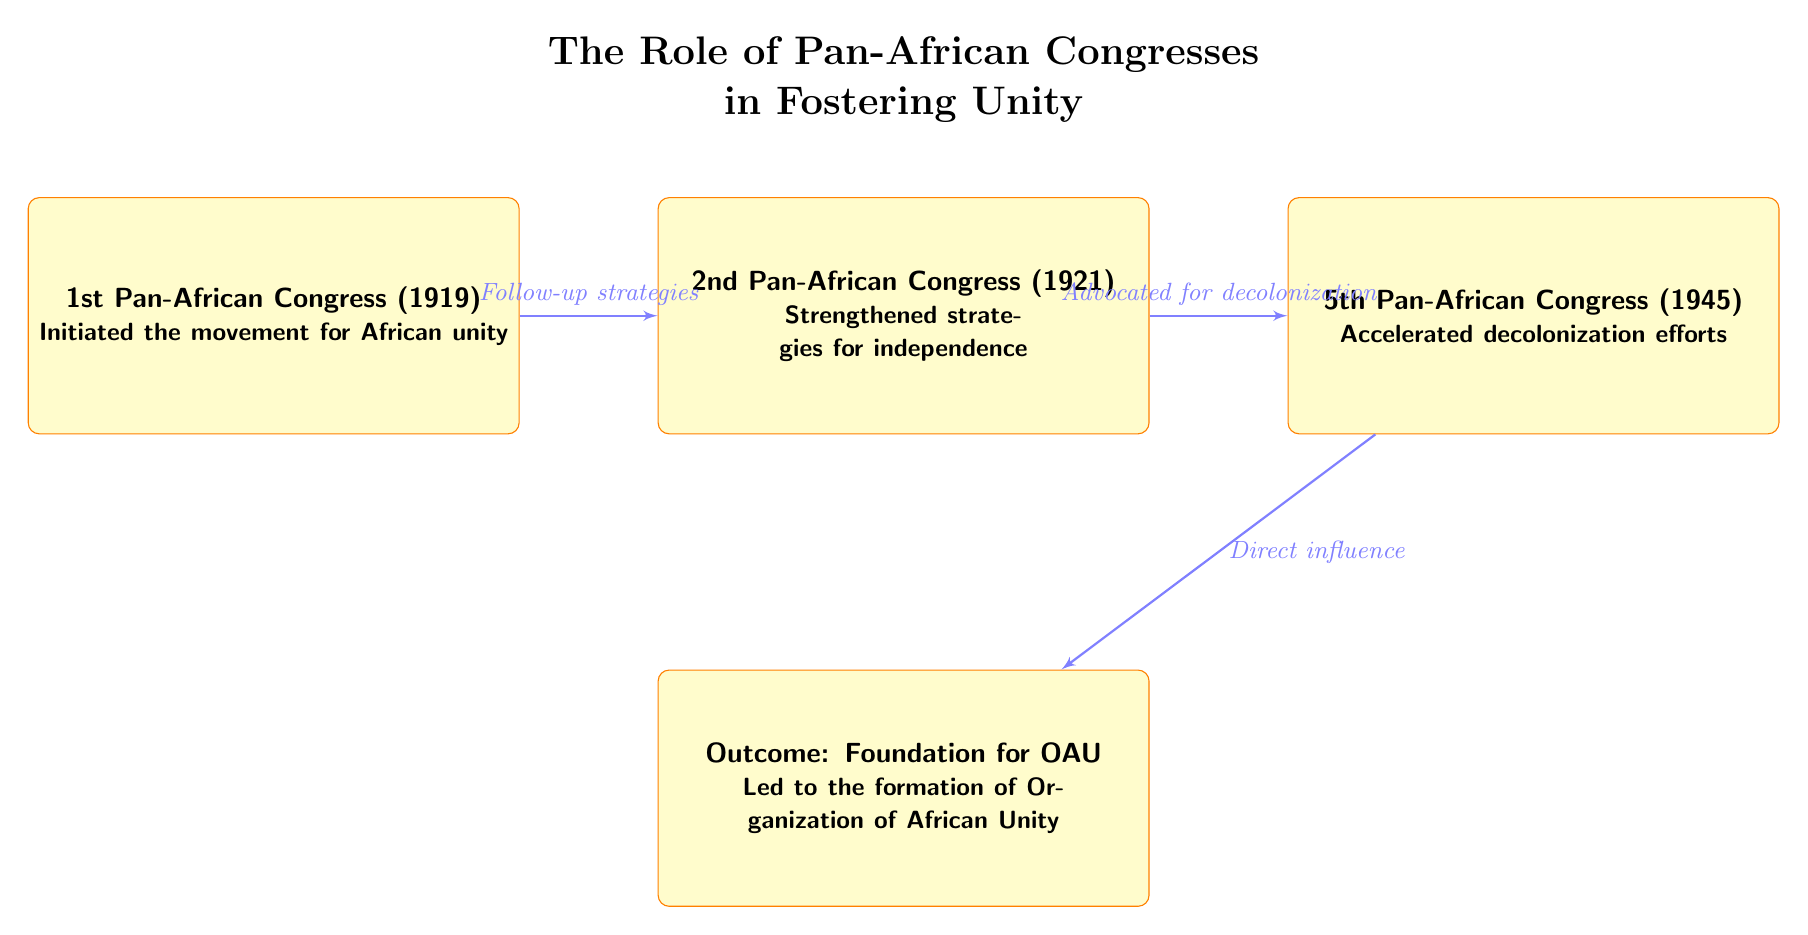What is the first event listed in the diagram? The diagram lists the 1st Pan-African Congress (1919) as the first event. This information is found in the first box at the top left of the flowchart.
Answer: 1st Pan-African Congress (1919) How many major congresses are depicted in the diagram? The diagram includes four major events: the 1st, 2nd, and 5th Pan-African Congresses, as well as the outcome that led to the foundation of the OAU. Counting these boxes shows there are four events in total.
Answer: 4 What was a key outcome of the 5th Pan-African Congress? The 5th Pan-African Congress (1945) resulted in the acceleration of decolonization efforts, as noted in the corresponding box. This outcome leads to the foundation of the OAU.
Answer: Accelerated decolonization efforts What connects the 2nd and 5th Pan-African Congresses? The connection is established through an arrow labeled "Advocated for decolonization," illustrating the flow of influence or strategies between these two congresses.
Answer: Advocated for decolonization What significant foundation resulted from the congresses outlined in the diagram? The diagram mentions that the outcome of the congresses led to the "Foundation for OAU," indicating a significant organizational result stemming from their discussions and strategies.
Answer: Foundation for OAU What year did the 2nd Pan-African Congress take place? The 2nd Pan-African Congress is identified as occurring in 1921 within the flowchart's information in the second box.
Answer: 1921 What do the arrows in the diagram represent? The arrows in the diagram represent the relationships and influences between the congress events, indicating sequential follow-ups and advocacy across the timeline of congresses.
Answer: Relationships and influences In which order are the congresses presented in the diagram? The congresses are presented in chronological order from the 1st in 1919, to the 2nd in 1921, and finally to the 5th in 1945, effectively demonstrating a historical timeline of events.
Answer: Chronological order: 1st, 2nd, 5th 